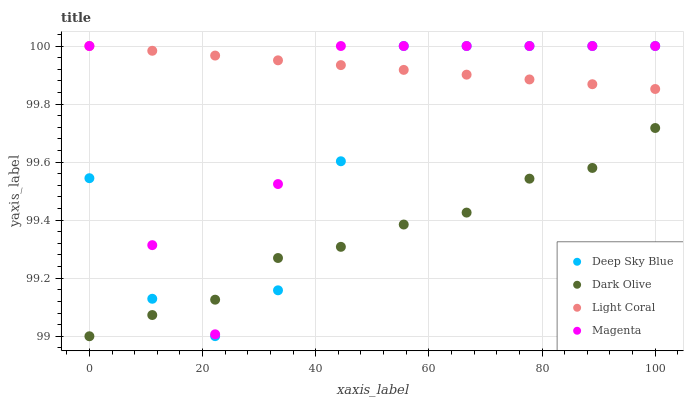Does Dark Olive have the minimum area under the curve?
Answer yes or no. Yes. Does Light Coral have the maximum area under the curve?
Answer yes or no. Yes. Does Magenta have the minimum area under the curve?
Answer yes or no. No. Does Magenta have the maximum area under the curve?
Answer yes or no. No. Is Light Coral the smoothest?
Answer yes or no. Yes. Is Magenta the roughest?
Answer yes or no. Yes. Is Dark Olive the smoothest?
Answer yes or no. No. Is Dark Olive the roughest?
Answer yes or no. No. Does Dark Olive have the lowest value?
Answer yes or no. Yes. Does Magenta have the lowest value?
Answer yes or no. No. Does Deep Sky Blue have the highest value?
Answer yes or no. Yes. Does Dark Olive have the highest value?
Answer yes or no. No. Is Dark Olive less than Light Coral?
Answer yes or no. Yes. Is Light Coral greater than Dark Olive?
Answer yes or no. Yes. Does Dark Olive intersect Deep Sky Blue?
Answer yes or no. Yes. Is Dark Olive less than Deep Sky Blue?
Answer yes or no. No. Is Dark Olive greater than Deep Sky Blue?
Answer yes or no. No. Does Dark Olive intersect Light Coral?
Answer yes or no. No. 